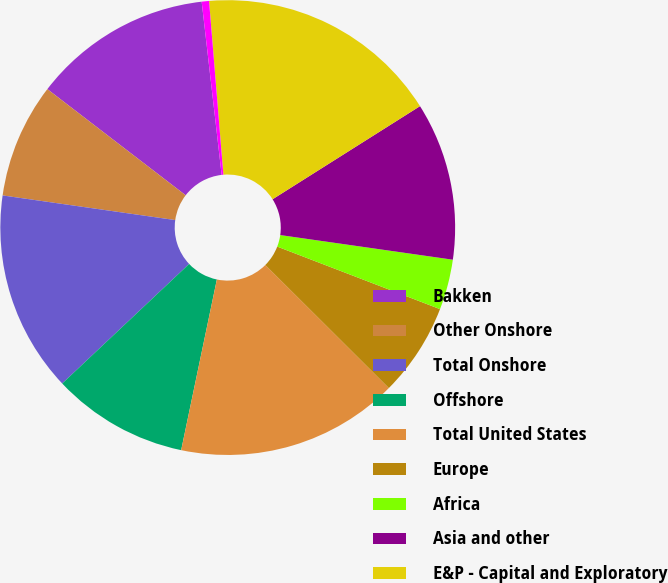<chart> <loc_0><loc_0><loc_500><loc_500><pie_chart><fcel>Bakken<fcel>Other Onshore<fcel>Total Onshore<fcel>Offshore<fcel>Total United States<fcel>Europe<fcel>Africa<fcel>Asia and other<fcel>E&P - Capital and Exploratory<fcel>United States<nl><fcel>12.75%<fcel>8.16%<fcel>14.28%<fcel>9.69%<fcel>15.81%<fcel>6.63%<fcel>3.58%<fcel>11.22%<fcel>17.34%<fcel>0.52%<nl></chart> 